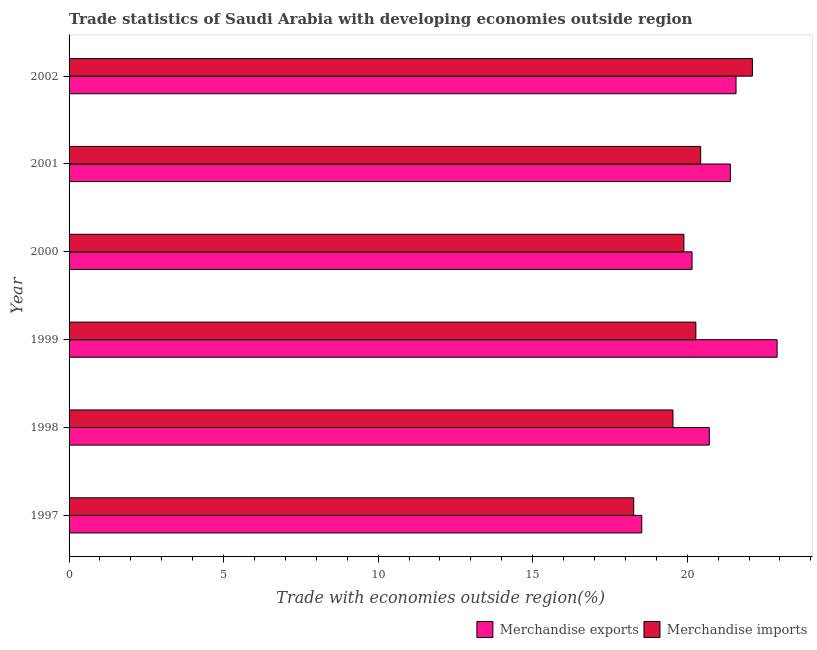How many different coloured bars are there?
Provide a short and direct response. 2. How many bars are there on the 4th tick from the top?
Give a very brief answer. 2. In how many cases, is the number of bars for a given year not equal to the number of legend labels?
Keep it short and to the point. 0. What is the merchandise exports in 2000?
Offer a terse response. 20.16. Across all years, what is the maximum merchandise imports?
Your answer should be very brief. 22.11. Across all years, what is the minimum merchandise imports?
Ensure brevity in your answer.  18.27. What is the total merchandise imports in the graph?
Give a very brief answer. 120.53. What is the difference between the merchandise exports in 1998 and that in 1999?
Give a very brief answer. -2.19. What is the difference between the merchandise imports in 2002 and the merchandise exports in 2001?
Provide a succinct answer. 0.71. What is the average merchandise imports per year?
Your answer should be very brief. 20.09. In the year 2000, what is the difference between the merchandise imports and merchandise exports?
Provide a succinct answer. -0.26. What is the ratio of the merchandise imports in 1998 to that in 1999?
Your answer should be compact. 0.96. What is the difference between the highest and the second highest merchandise exports?
Offer a very short reply. 1.33. What is the difference between the highest and the lowest merchandise imports?
Your answer should be compact. 3.84. In how many years, is the merchandise exports greater than the average merchandise exports taken over all years?
Offer a very short reply. 3. How many bars are there?
Provide a succinct answer. 12. Are all the bars in the graph horizontal?
Your answer should be compact. Yes. How many years are there in the graph?
Offer a very short reply. 6. Does the graph contain any zero values?
Your answer should be compact. No. What is the title of the graph?
Ensure brevity in your answer.  Trade statistics of Saudi Arabia with developing economies outside region. Does "RDB concessional" appear as one of the legend labels in the graph?
Keep it short and to the point. No. What is the label or title of the X-axis?
Provide a succinct answer. Trade with economies outside region(%). What is the Trade with economies outside region(%) in Merchandise exports in 1997?
Keep it short and to the point. 18.53. What is the Trade with economies outside region(%) in Merchandise imports in 1997?
Your response must be concise. 18.27. What is the Trade with economies outside region(%) in Merchandise exports in 1998?
Your answer should be compact. 20.72. What is the Trade with economies outside region(%) of Merchandise imports in 1998?
Give a very brief answer. 19.54. What is the Trade with economies outside region(%) in Merchandise exports in 1999?
Your answer should be compact. 22.91. What is the Trade with economies outside region(%) in Merchandise imports in 1999?
Keep it short and to the point. 20.28. What is the Trade with economies outside region(%) in Merchandise exports in 2000?
Your answer should be compact. 20.16. What is the Trade with economies outside region(%) of Merchandise imports in 2000?
Offer a terse response. 19.89. What is the Trade with economies outside region(%) in Merchandise exports in 2001?
Offer a very short reply. 21.4. What is the Trade with economies outside region(%) of Merchandise imports in 2001?
Keep it short and to the point. 20.44. What is the Trade with economies outside region(%) of Merchandise exports in 2002?
Ensure brevity in your answer.  21.58. What is the Trade with economies outside region(%) of Merchandise imports in 2002?
Ensure brevity in your answer.  22.11. Across all years, what is the maximum Trade with economies outside region(%) in Merchandise exports?
Ensure brevity in your answer.  22.91. Across all years, what is the maximum Trade with economies outside region(%) in Merchandise imports?
Your answer should be compact. 22.11. Across all years, what is the minimum Trade with economies outside region(%) in Merchandise exports?
Offer a very short reply. 18.53. Across all years, what is the minimum Trade with economies outside region(%) of Merchandise imports?
Your answer should be very brief. 18.27. What is the total Trade with economies outside region(%) in Merchandise exports in the graph?
Make the answer very short. 125.28. What is the total Trade with economies outside region(%) in Merchandise imports in the graph?
Offer a terse response. 120.53. What is the difference between the Trade with economies outside region(%) in Merchandise exports in 1997 and that in 1998?
Your answer should be very brief. -2.19. What is the difference between the Trade with economies outside region(%) in Merchandise imports in 1997 and that in 1998?
Your answer should be compact. -1.27. What is the difference between the Trade with economies outside region(%) of Merchandise exports in 1997 and that in 1999?
Your answer should be compact. -4.38. What is the difference between the Trade with economies outside region(%) in Merchandise imports in 1997 and that in 1999?
Your answer should be very brief. -2.01. What is the difference between the Trade with economies outside region(%) of Merchandise exports in 1997 and that in 2000?
Make the answer very short. -1.63. What is the difference between the Trade with economies outside region(%) in Merchandise imports in 1997 and that in 2000?
Provide a short and direct response. -1.62. What is the difference between the Trade with economies outside region(%) of Merchandise exports in 1997 and that in 2001?
Make the answer very short. -2.87. What is the difference between the Trade with economies outside region(%) of Merchandise imports in 1997 and that in 2001?
Provide a succinct answer. -2.17. What is the difference between the Trade with economies outside region(%) in Merchandise exports in 1997 and that in 2002?
Offer a terse response. -3.05. What is the difference between the Trade with economies outside region(%) of Merchandise imports in 1997 and that in 2002?
Your answer should be compact. -3.84. What is the difference between the Trade with economies outside region(%) of Merchandise exports in 1998 and that in 1999?
Your response must be concise. -2.19. What is the difference between the Trade with economies outside region(%) of Merchandise imports in 1998 and that in 1999?
Offer a very short reply. -0.74. What is the difference between the Trade with economies outside region(%) in Merchandise exports in 1998 and that in 2000?
Offer a terse response. 0.56. What is the difference between the Trade with economies outside region(%) of Merchandise imports in 1998 and that in 2000?
Make the answer very short. -0.35. What is the difference between the Trade with economies outside region(%) of Merchandise exports in 1998 and that in 2001?
Keep it short and to the point. -0.68. What is the difference between the Trade with economies outside region(%) of Merchandise imports in 1998 and that in 2001?
Your answer should be compact. -0.9. What is the difference between the Trade with economies outside region(%) in Merchandise exports in 1998 and that in 2002?
Your response must be concise. -0.86. What is the difference between the Trade with economies outside region(%) in Merchandise imports in 1998 and that in 2002?
Provide a succinct answer. -2.57. What is the difference between the Trade with economies outside region(%) of Merchandise exports in 1999 and that in 2000?
Your answer should be very brief. 2.75. What is the difference between the Trade with economies outside region(%) in Merchandise imports in 1999 and that in 2000?
Give a very brief answer. 0.39. What is the difference between the Trade with economies outside region(%) in Merchandise exports in 1999 and that in 2001?
Ensure brevity in your answer.  1.51. What is the difference between the Trade with economies outside region(%) of Merchandise imports in 1999 and that in 2001?
Provide a succinct answer. -0.16. What is the difference between the Trade with economies outside region(%) of Merchandise exports in 1999 and that in 2002?
Your answer should be very brief. 1.33. What is the difference between the Trade with economies outside region(%) in Merchandise imports in 1999 and that in 2002?
Your answer should be compact. -1.83. What is the difference between the Trade with economies outside region(%) of Merchandise exports in 2000 and that in 2001?
Give a very brief answer. -1.24. What is the difference between the Trade with economies outside region(%) in Merchandise imports in 2000 and that in 2001?
Give a very brief answer. -0.54. What is the difference between the Trade with economies outside region(%) in Merchandise exports in 2000 and that in 2002?
Offer a terse response. -1.42. What is the difference between the Trade with economies outside region(%) in Merchandise imports in 2000 and that in 2002?
Your answer should be very brief. -2.22. What is the difference between the Trade with economies outside region(%) of Merchandise exports in 2001 and that in 2002?
Give a very brief answer. -0.18. What is the difference between the Trade with economies outside region(%) of Merchandise imports in 2001 and that in 2002?
Ensure brevity in your answer.  -1.67. What is the difference between the Trade with economies outside region(%) of Merchandise exports in 1997 and the Trade with economies outside region(%) of Merchandise imports in 1998?
Your response must be concise. -1.01. What is the difference between the Trade with economies outside region(%) of Merchandise exports in 1997 and the Trade with economies outside region(%) of Merchandise imports in 1999?
Offer a terse response. -1.75. What is the difference between the Trade with economies outside region(%) of Merchandise exports in 1997 and the Trade with economies outside region(%) of Merchandise imports in 2000?
Provide a succinct answer. -1.36. What is the difference between the Trade with economies outside region(%) of Merchandise exports in 1997 and the Trade with economies outside region(%) of Merchandise imports in 2001?
Ensure brevity in your answer.  -1.91. What is the difference between the Trade with economies outside region(%) of Merchandise exports in 1997 and the Trade with economies outside region(%) of Merchandise imports in 2002?
Keep it short and to the point. -3.58. What is the difference between the Trade with economies outside region(%) of Merchandise exports in 1998 and the Trade with economies outside region(%) of Merchandise imports in 1999?
Offer a terse response. 0.44. What is the difference between the Trade with economies outside region(%) in Merchandise exports in 1998 and the Trade with economies outside region(%) in Merchandise imports in 2000?
Provide a succinct answer. 0.82. What is the difference between the Trade with economies outside region(%) in Merchandise exports in 1998 and the Trade with economies outside region(%) in Merchandise imports in 2001?
Keep it short and to the point. 0.28. What is the difference between the Trade with economies outside region(%) in Merchandise exports in 1998 and the Trade with economies outside region(%) in Merchandise imports in 2002?
Offer a very short reply. -1.39. What is the difference between the Trade with economies outside region(%) in Merchandise exports in 1999 and the Trade with economies outside region(%) in Merchandise imports in 2000?
Offer a terse response. 3.02. What is the difference between the Trade with economies outside region(%) of Merchandise exports in 1999 and the Trade with economies outside region(%) of Merchandise imports in 2001?
Provide a succinct answer. 2.47. What is the difference between the Trade with economies outside region(%) of Merchandise exports in 1999 and the Trade with economies outside region(%) of Merchandise imports in 2002?
Your response must be concise. 0.8. What is the difference between the Trade with economies outside region(%) of Merchandise exports in 2000 and the Trade with economies outside region(%) of Merchandise imports in 2001?
Your response must be concise. -0.28. What is the difference between the Trade with economies outside region(%) in Merchandise exports in 2000 and the Trade with economies outside region(%) in Merchandise imports in 2002?
Make the answer very short. -1.95. What is the difference between the Trade with economies outside region(%) of Merchandise exports in 2001 and the Trade with economies outside region(%) of Merchandise imports in 2002?
Provide a succinct answer. -0.71. What is the average Trade with economies outside region(%) in Merchandise exports per year?
Offer a very short reply. 20.88. What is the average Trade with economies outside region(%) in Merchandise imports per year?
Offer a terse response. 20.09. In the year 1997, what is the difference between the Trade with economies outside region(%) of Merchandise exports and Trade with economies outside region(%) of Merchandise imports?
Offer a terse response. 0.26. In the year 1998, what is the difference between the Trade with economies outside region(%) in Merchandise exports and Trade with economies outside region(%) in Merchandise imports?
Give a very brief answer. 1.18. In the year 1999, what is the difference between the Trade with economies outside region(%) in Merchandise exports and Trade with economies outside region(%) in Merchandise imports?
Offer a very short reply. 2.63. In the year 2000, what is the difference between the Trade with economies outside region(%) of Merchandise exports and Trade with economies outside region(%) of Merchandise imports?
Your answer should be compact. 0.26. In the year 2001, what is the difference between the Trade with economies outside region(%) in Merchandise exports and Trade with economies outside region(%) in Merchandise imports?
Provide a succinct answer. 0.96. In the year 2002, what is the difference between the Trade with economies outside region(%) in Merchandise exports and Trade with economies outside region(%) in Merchandise imports?
Offer a terse response. -0.53. What is the ratio of the Trade with economies outside region(%) of Merchandise exports in 1997 to that in 1998?
Offer a terse response. 0.89. What is the ratio of the Trade with economies outside region(%) in Merchandise imports in 1997 to that in 1998?
Make the answer very short. 0.94. What is the ratio of the Trade with economies outside region(%) of Merchandise exports in 1997 to that in 1999?
Ensure brevity in your answer.  0.81. What is the ratio of the Trade with economies outside region(%) in Merchandise imports in 1997 to that in 1999?
Offer a very short reply. 0.9. What is the ratio of the Trade with economies outside region(%) in Merchandise exports in 1997 to that in 2000?
Offer a terse response. 0.92. What is the ratio of the Trade with economies outside region(%) in Merchandise imports in 1997 to that in 2000?
Make the answer very short. 0.92. What is the ratio of the Trade with economies outside region(%) in Merchandise exports in 1997 to that in 2001?
Provide a short and direct response. 0.87. What is the ratio of the Trade with economies outside region(%) of Merchandise imports in 1997 to that in 2001?
Your answer should be compact. 0.89. What is the ratio of the Trade with economies outside region(%) in Merchandise exports in 1997 to that in 2002?
Offer a very short reply. 0.86. What is the ratio of the Trade with economies outside region(%) of Merchandise imports in 1997 to that in 2002?
Ensure brevity in your answer.  0.83. What is the ratio of the Trade with economies outside region(%) of Merchandise exports in 1998 to that in 1999?
Your response must be concise. 0.9. What is the ratio of the Trade with economies outside region(%) of Merchandise imports in 1998 to that in 1999?
Provide a succinct answer. 0.96. What is the ratio of the Trade with economies outside region(%) in Merchandise exports in 1998 to that in 2000?
Keep it short and to the point. 1.03. What is the ratio of the Trade with economies outside region(%) of Merchandise imports in 1998 to that in 2000?
Your answer should be compact. 0.98. What is the ratio of the Trade with economies outside region(%) in Merchandise exports in 1998 to that in 2001?
Offer a very short reply. 0.97. What is the ratio of the Trade with economies outside region(%) of Merchandise imports in 1998 to that in 2001?
Provide a succinct answer. 0.96. What is the ratio of the Trade with economies outside region(%) in Merchandise exports in 1998 to that in 2002?
Offer a very short reply. 0.96. What is the ratio of the Trade with economies outside region(%) in Merchandise imports in 1998 to that in 2002?
Keep it short and to the point. 0.88. What is the ratio of the Trade with economies outside region(%) in Merchandise exports in 1999 to that in 2000?
Your answer should be compact. 1.14. What is the ratio of the Trade with economies outside region(%) in Merchandise imports in 1999 to that in 2000?
Your response must be concise. 1.02. What is the ratio of the Trade with economies outside region(%) of Merchandise exports in 1999 to that in 2001?
Your answer should be very brief. 1.07. What is the ratio of the Trade with economies outside region(%) of Merchandise imports in 1999 to that in 2001?
Keep it short and to the point. 0.99. What is the ratio of the Trade with economies outside region(%) of Merchandise exports in 1999 to that in 2002?
Offer a very short reply. 1.06. What is the ratio of the Trade with economies outside region(%) in Merchandise imports in 1999 to that in 2002?
Ensure brevity in your answer.  0.92. What is the ratio of the Trade with economies outside region(%) in Merchandise exports in 2000 to that in 2001?
Make the answer very short. 0.94. What is the ratio of the Trade with economies outside region(%) in Merchandise imports in 2000 to that in 2001?
Your response must be concise. 0.97. What is the ratio of the Trade with economies outside region(%) of Merchandise exports in 2000 to that in 2002?
Make the answer very short. 0.93. What is the ratio of the Trade with economies outside region(%) in Merchandise imports in 2000 to that in 2002?
Your answer should be compact. 0.9. What is the ratio of the Trade with economies outside region(%) in Merchandise exports in 2001 to that in 2002?
Offer a very short reply. 0.99. What is the ratio of the Trade with economies outside region(%) in Merchandise imports in 2001 to that in 2002?
Give a very brief answer. 0.92. What is the difference between the highest and the second highest Trade with economies outside region(%) of Merchandise exports?
Ensure brevity in your answer.  1.33. What is the difference between the highest and the second highest Trade with economies outside region(%) of Merchandise imports?
Give a very brief answer. 1.67. What is the difference between the highest and the lowest Trade with economies outside region(%) in Merchandise exports?
Offer a terse response. 4.38. What is the difference between the highest and the lowest Trade with economies outside region(%) in Merchandise imports?
Provide a succinct answer. 3.84. 